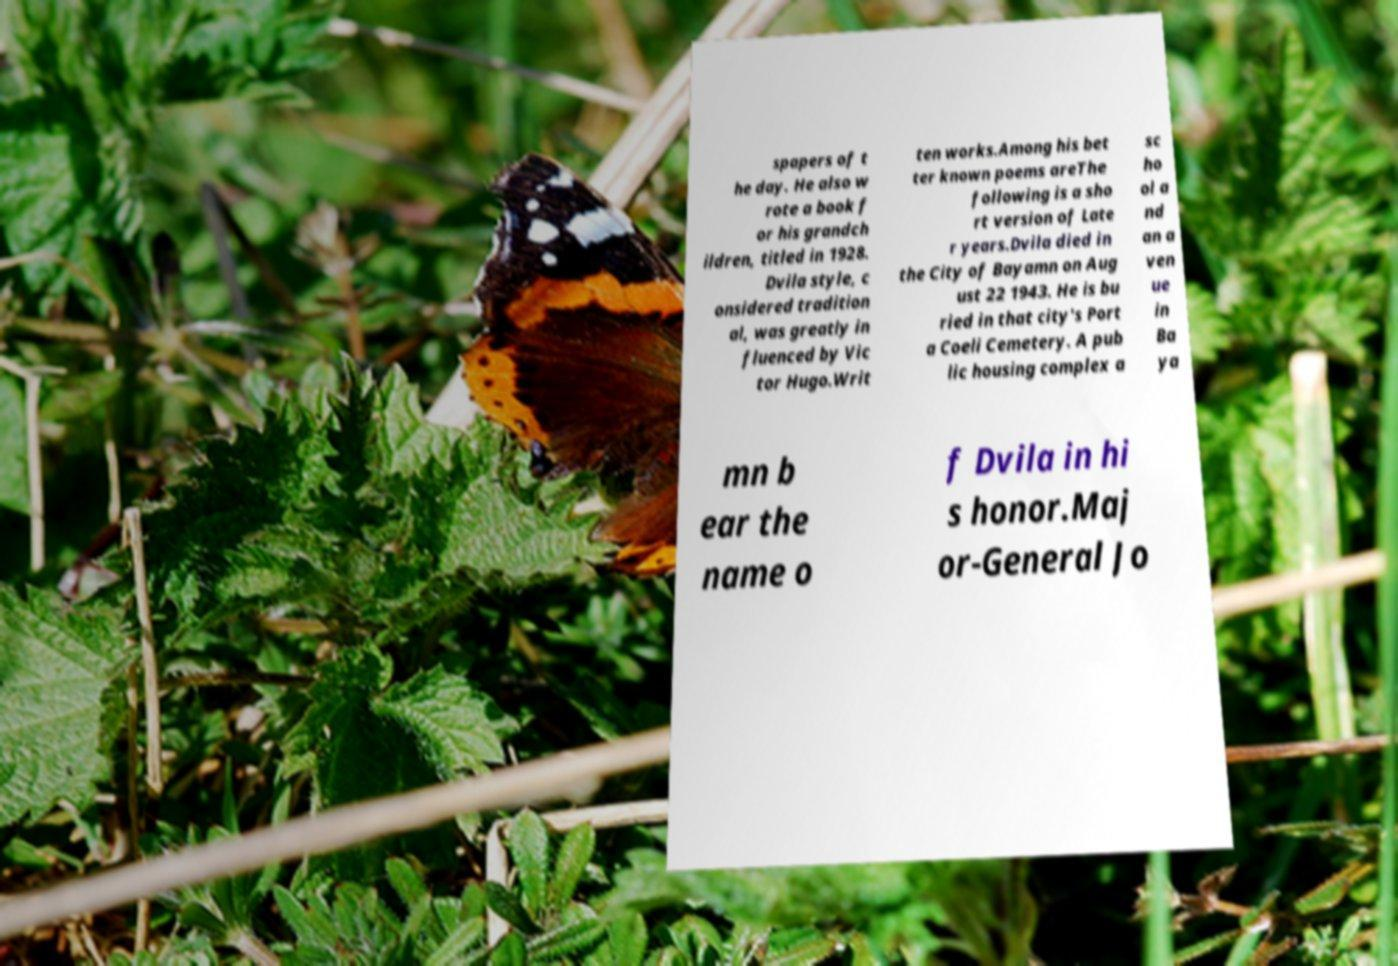There's text embedded in this image that I need extracted. Can you transcribe it verbatim? spapers of t he day. He also w rote a book f or his grandch ildren, titled in 1928. Dvila style, c onsidered tradition al, was greatly in fluenced by Vic tor Hugo.Writ ten works.Among his bet ter known poems areThe following is a sho rt version of Late r years.Dvila died in the City of Bayamn on Aug ust 22 1943. He is bu ried in that city's Port a Coeli Cemetery. A pub lic housing complex a sc ho ol a nd an a ven ue in Ba ya mn b ear the name o f Dvila in hi s honor.Maj or-General Jo 